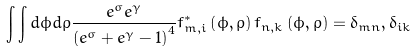Convert formula to latex. <formula><loc_0><loc_0><loc_500><loc_500>\int \int d \phi d \rho \frac { e ^ { \sigma } e ^ { \gamma } } { \left ( e ^ { \sigma } + e ^ { \gamma } - 1 \right ) ^ { 4 } } f _ { m , i } ^ { \ast } \left ( \phi , \rho \right ) f _ { n , k } \left ( \phi , \rho \right ) = \delta _ { m n } , \delta _ { i k }</formula> 